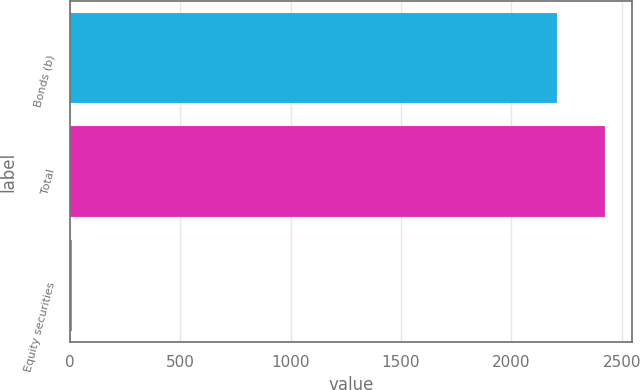Convert chart to OTSL. <chart><loc_0><loc_0><loc_500><loc_500><bar_chart><fcel>Bonds (b)<fcel>Total<fcel>Equity securities<nl><fcel>2206<fcel>2425.5<fcel>11<nl></chart> 